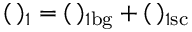Convert formula to latex. <formula><loc_0><loc_0><loc_500><loc_500>( \, ) _ { 1 } = ( \, ) _ { 1 b g } + ( \, ) _ { 1 s c }</formula> 